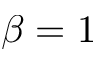Convert formula to latex. <formula><loc_0><loc_0><loc_500><loc_500>\beta = 1</formula> 